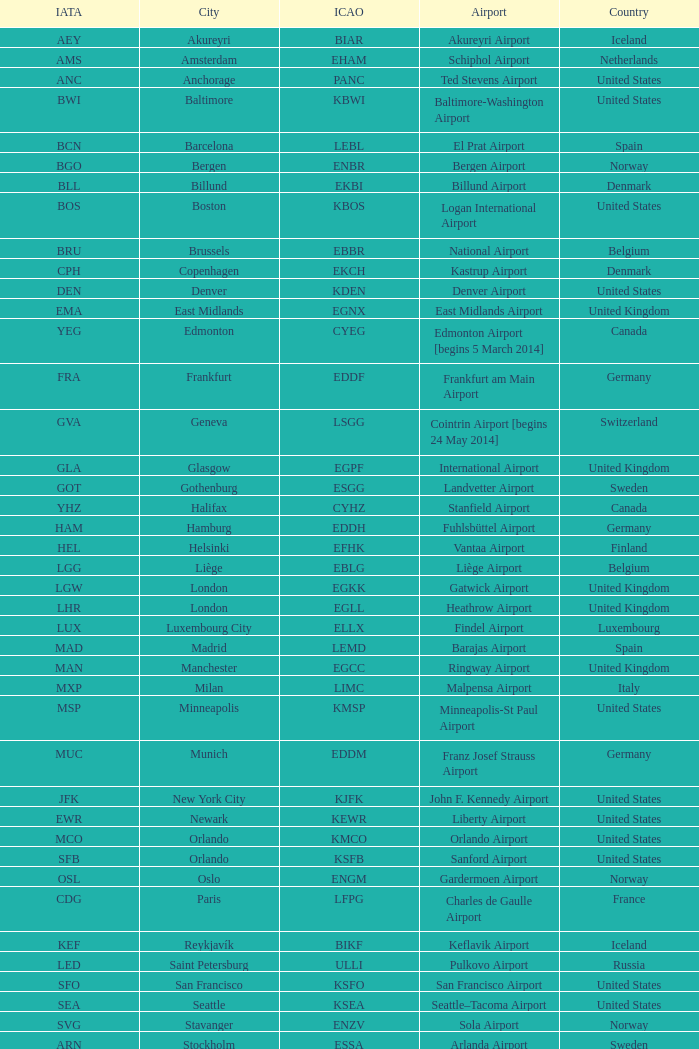What is the Airport with the ICAO fo KSEA? Seattle–Tacoma Airport. 